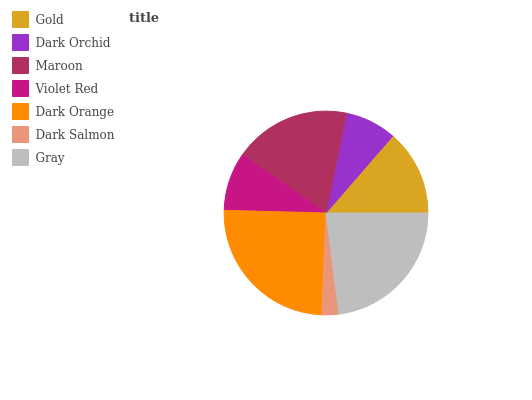Is Dark Salmon the minimum?
Answer yes or no. Yes. Is Dark Orange the maximum?
Answer yes or no. Yes. Is Dark Orchid the minimum?
Answer yes or no. No. Is Dark Orchid the maximum?
Answer yes or no. No. Is Gold greater than Dark Orchid?
Answer yes or no. Yes. Is Dark Orchid less than Gold?
Answer yes or no. Yes. Is Dark Orchid greater than Gold?
Answer yes or no. No. Is Gold less than Dark Orchid?
Answer yes or no. No. Is Gold the high median?
Answer yes or no. Yes. Is Gold the low median?
Answer yes or no. Yes. Is Gray the high median?
Answer yes or no. No. Is Dark Orchid the low median?
Answer yes or no. No. 